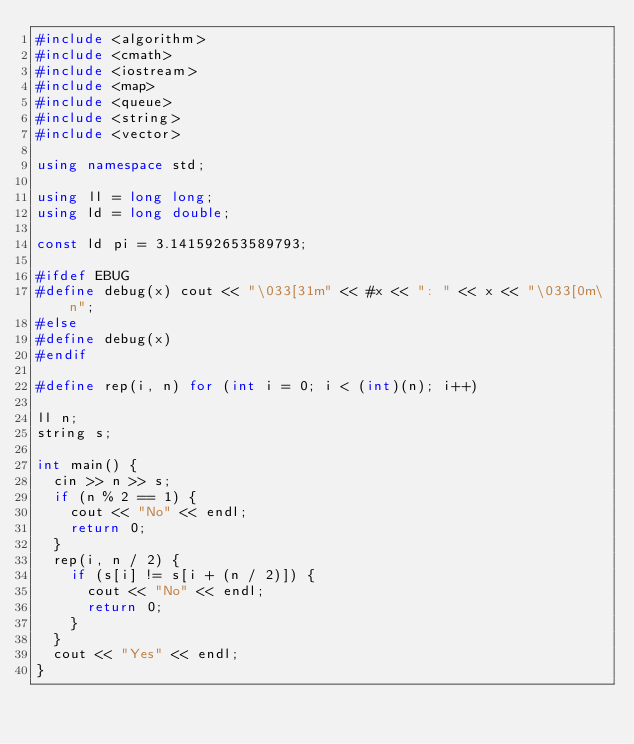<code> <loc_0><loc_0><loc_500><loc_500><_C++_>#include <algorithm>
#include <cmath>
#include <iostream>
#include <map>
#include <queue>
#include <string>
#include <vector>

using namespace std;

using ll = long long;
using ld = long double;

const ld pi = 3.141592653589793;

#ifdef EBUG
#define debug(x) cout << "\033[31m" << #x << ": " << x << "\033[0m\n";
#else
#define debug(x)
#endif

#define rep(i, n) for (int i = 0; i < (int)(n); i++)

ll n;
string s;

int main() {
  cin >> n >> s;
  if (n % 2 == 1) {
    cout << "No" << endl;
    return 0;
  }
  rep(i, n / 2) {
    if (s[i] != s[i + (n / 2)]) {
      cout << "No" << endl;
      return 0;
    }
  }
  cout << "Yes" << endl;
}</code> 